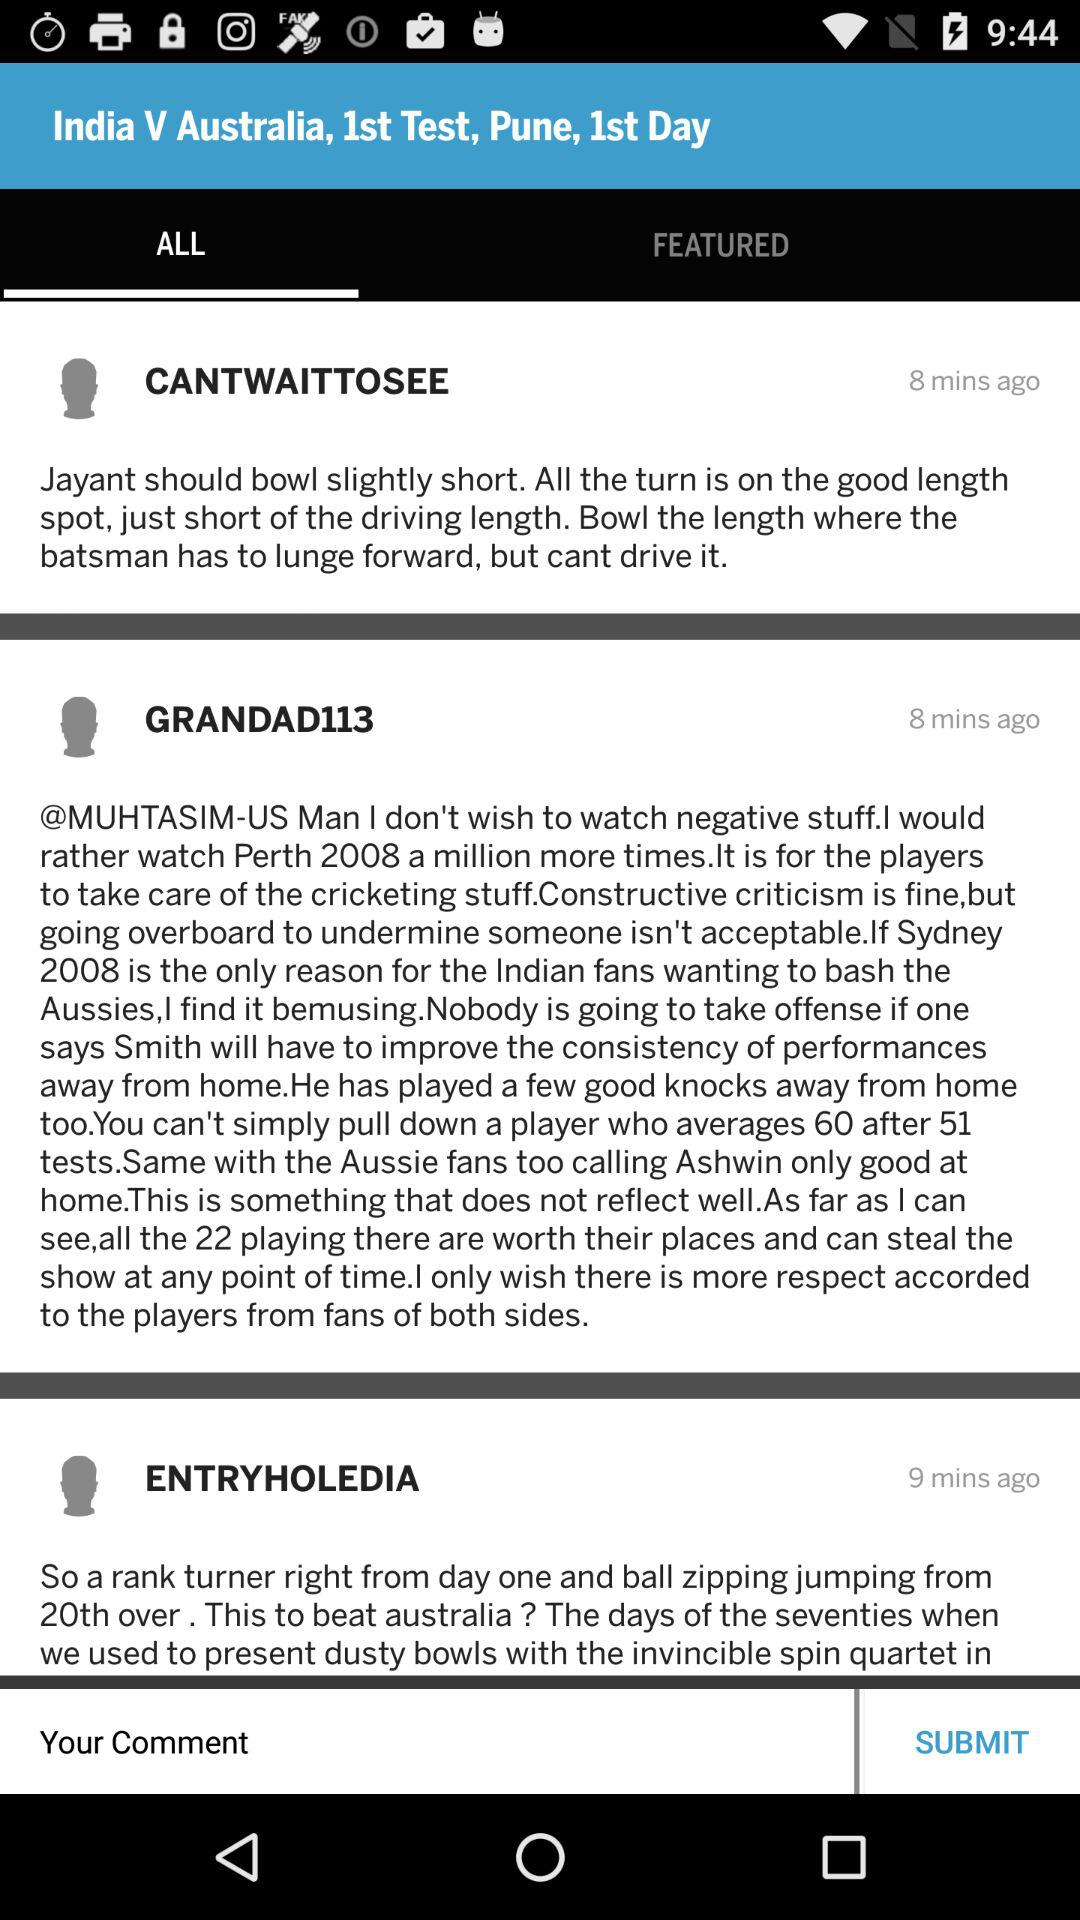Which countries will be the first to face off?
When the provided information is insufficient, respond with <no answer>. <no answer> 